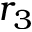<formula> <loc_0><loc_0><loc_500><loc_500>r _ { 3 }</formula> 